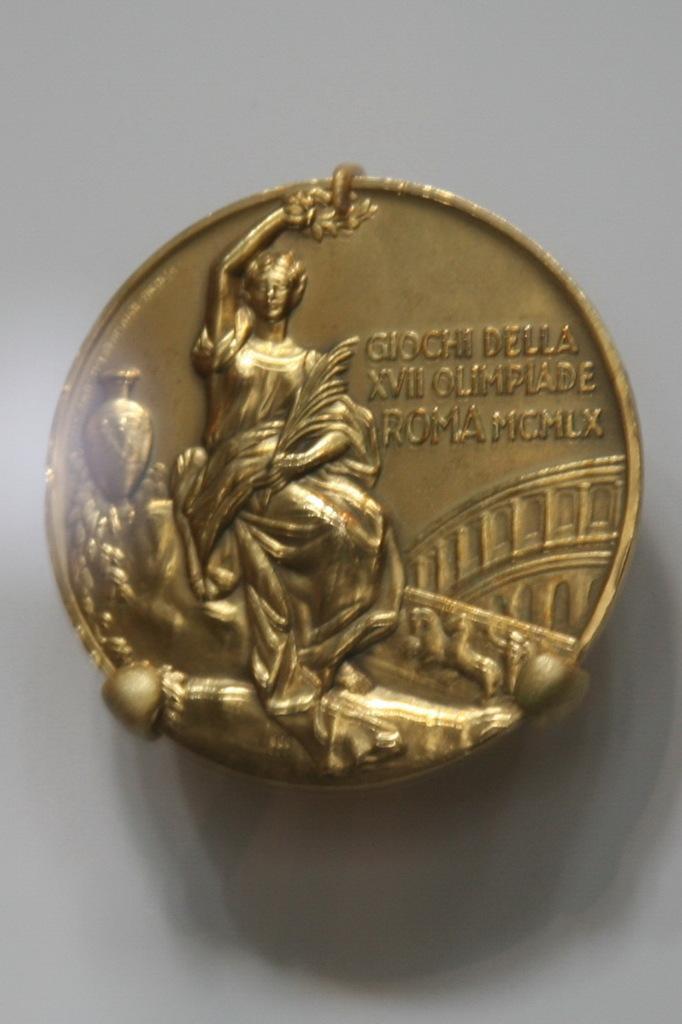Can you describe this image briefly? In the foreground I can see a metal coin, text and a person's sculpture on it. In the background I can see a wall. This image is taken may be in a room. 